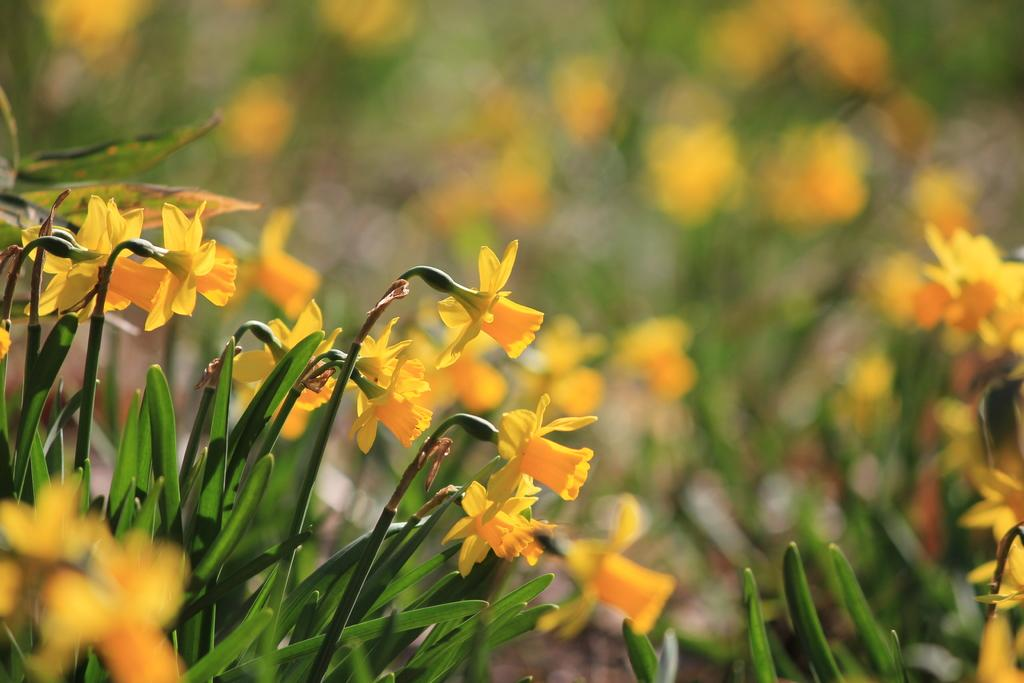What color are the flowers on the plants in the image? The flowers on the plants in the image are yellow. Can you describe the background of the image? The background of the image is blurred. What type of fire can be seen coming from the clock in the image? There is no fire or clock present in the image; it features yellow flowers on plants with a blurred background. 